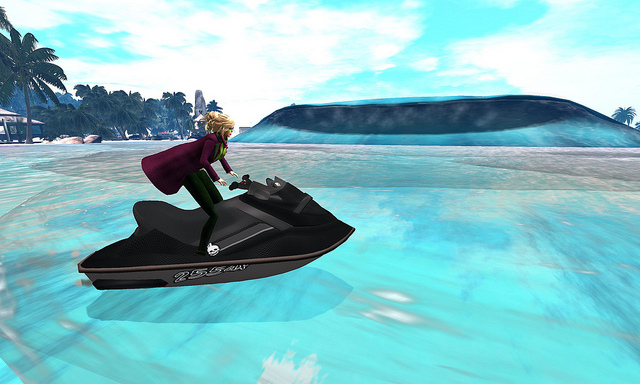Please identify all text content in this image. 255 